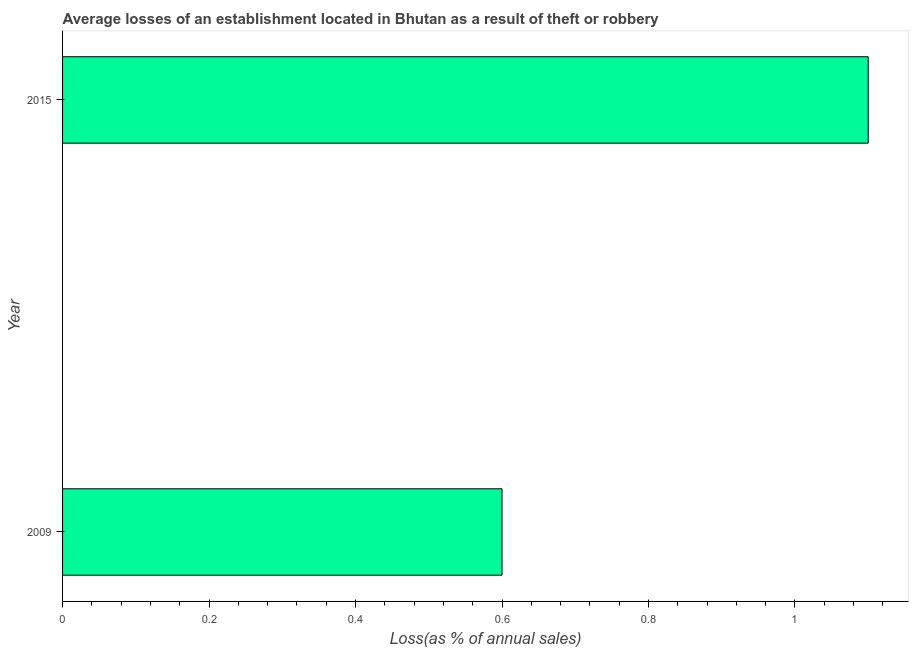Does the graph contain grids?
Make the answer very short. No. What is the title of the graph?
Offer a very short reply. Average losses of an establishment located in Bhutan as a result of theft or robbery. What is the label or title of the X-axis?
Provide a short and direct response. Loss(as % of annual sales). Across all years, what is the maximum losses due to theft?
Ensure brevity in your answer.  1.1. In which year was the losses due to theft maximum?
Ensure brevity in your answer.  2015. What is the sum of the losses due to theft?
Keep it short and to the point. 1.7. What is the difference between the losses due to theft in 2009 and 2015?
Give a very brief answer. -0.5. What is the average losses due to theft per year?
Your answer should be compact. 0.85. What is the median losses due to theft?
Provide a short and direct response. 0.85. What is the ratio of the losses due to theft in 2009 to that in 2015?
Offer a very short reply. 0.55. In how many years, is the losses due to theft greater than the average losses due to theft taken over all years?
Provide a short and direct response. 1. How many bars are there?
Provide a short and direct response. 2. What is the difference between two consecutive major ticks on the X-axis?
Ensure brevity in your answer.  0.2. What is the Loss(as % of annual sales) of 2009?
Provide a short and direct response. 0.6. What is the ratio of the Loss(as % of annual sales) in 2009 to that in 2015?
Your response must be concise. 0.55. 